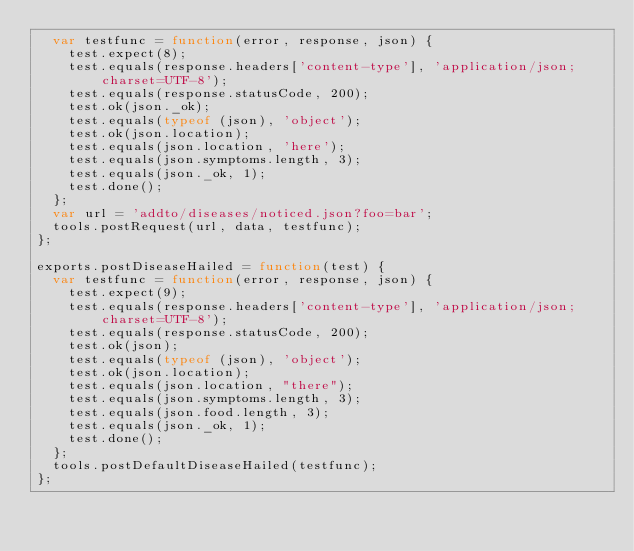<code> <loc_0><loc_0><loc_500><loc_500><_JavaScript_>  var testfunc = function(error, response, json) {
    test.expect(8);
    test.equals(response.headers['content-type'], 'application/json; charset=UTF-8');
    test.equals(response.statusCode, 200);
    test.ok(json._ok);
    test.equals(typeof (json), 'object');
    test.ok(json.location);
    test.equals(json.location, 'here');
    test.equals(json.symptoms.length, 3);
    test.equals(json._ok, 1);
    test.done();
  };
  var url = 'addto/diseases/noticed.json?foo=bar';
  tools.postRequest(url, data, testfunc);
};

exports.postDiseaseHailed = function(test) {
  var testfunc = function(error, response, json) {
    test.expect(9);
    test.equals(response.headers['content-type'], 'application/json; charset=UTF-8');
    test.equals(response.statusCode, 200);
    test.ok(json);
    test.equals(typeof (json), 'object');
    test.ok(json.location);
    test.equals(json.location, "there");
    test.equals(json.symptoms.length, 3);
    test.equals(json.food.length, 3);
    test.equals(json._ok, 1);
    test.done();
  };
  tools.postDefaultDiseaseHailed(testfunc);
};
</code> 